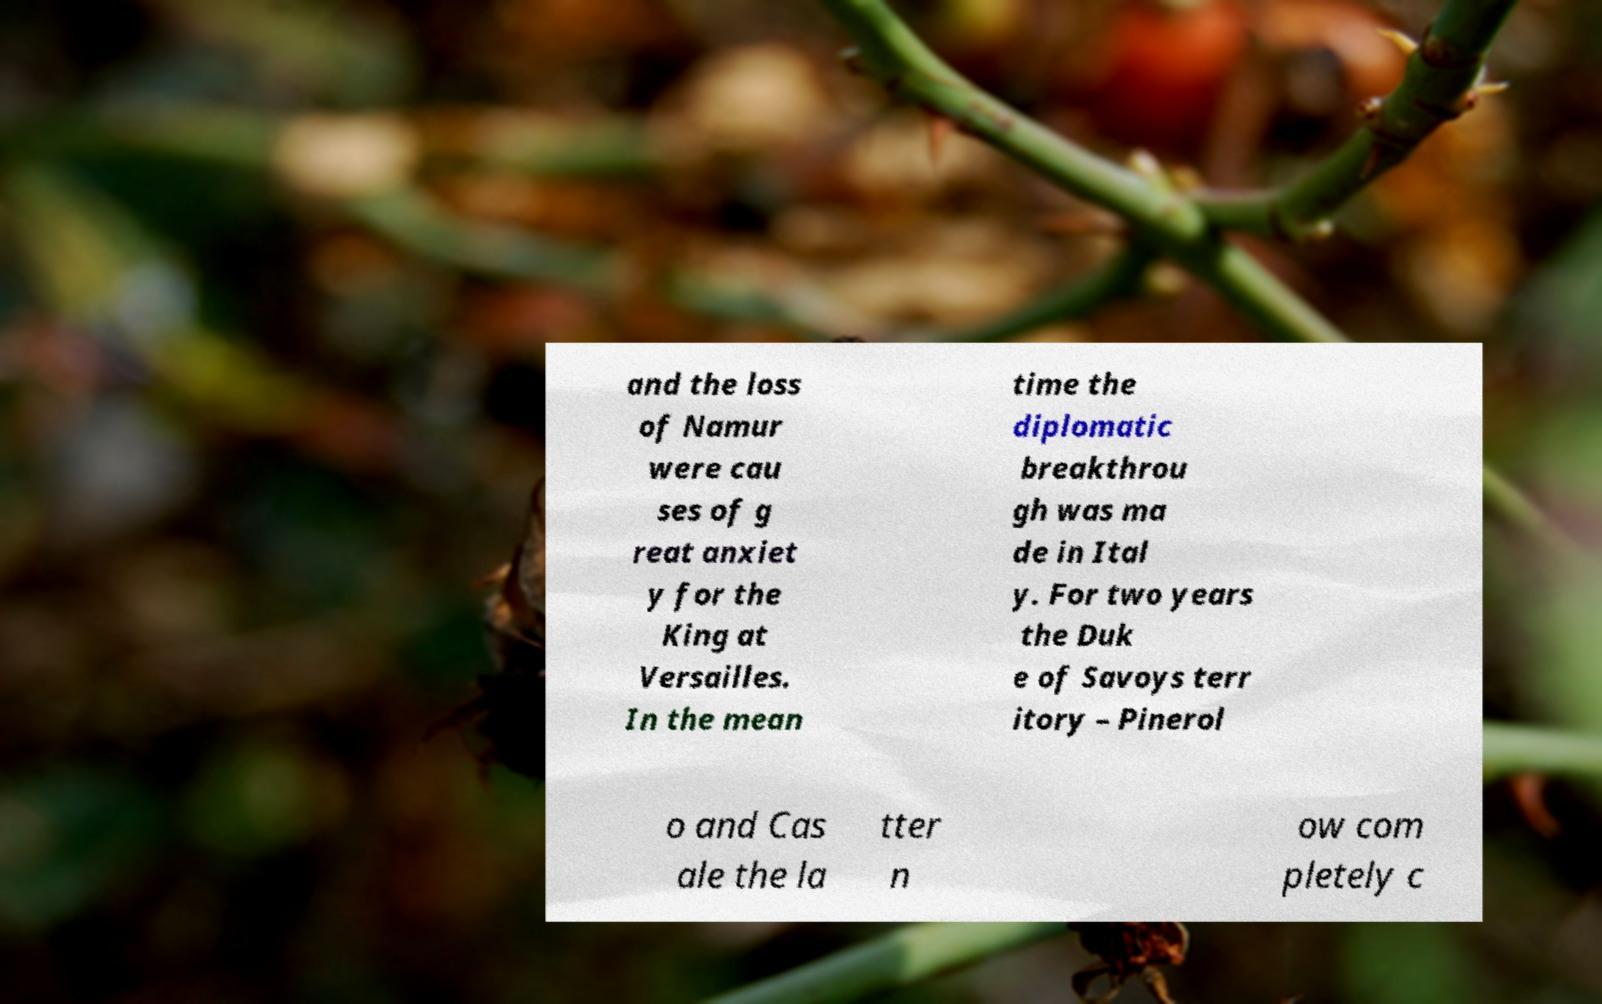Could you assist in decoding the text presented in this image and type it out clearly? and the loss of Namur were cau ses of g reat anxiet y for the King at Versailles. In the mean time the diplomatic breakthrou gh was ma de in Ital y. For two years the Duk e of Savoys terr itory – Pinerol o and Cas ale the la tter n ow com pletely c 